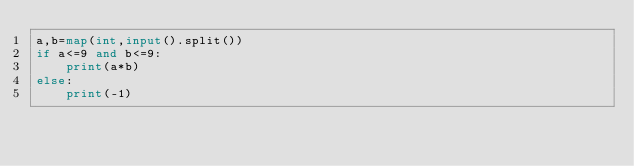Convert code to text. <code><loc_0><loc_0><loc_500><loc_500><_Python_>a,b=map(int,input().split())
if a<=9 and b<=9:
    print(a*b)
else:
    print(-1)</code> 